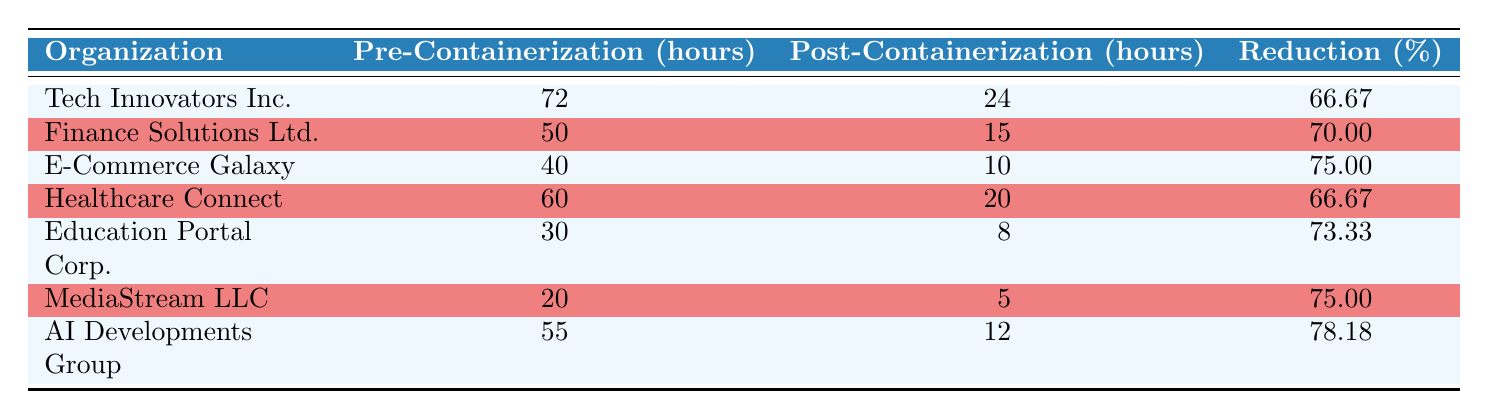What was the pre-containerization deployment time for E-Commerce Galaxy? The table shows that E-Commerce Galaxy had a pre-containerization deployment time of 40 hours.
Answer: 40 hours Which organization had the highest reduction percentage in deployment time? The organization with the highest reduction percentage is AI Developments Group, with a reduction of 78.18%.
Answer: AI Developments Group What is the total pre-containerization deployment time for all organizations? Adding up all the pre-containerization times gives us: 72 + 50 + 40 + 60 + 30 + 20 + 55 = 327 hours.
Answer: 327 hours Did Finance Solutions Ltd. have a reduction percentage of over 70%? According to the table, Finance Solutions Ltd. had a reduction percentage of 70.00%, which is equal to 70% but not greater than it.
Answer: No What is the average post-containerization deployment time across all organizations? To find the average, sum the post-containerization times: 24 + 15 + 10 + 20 + 8 + 5 + 12 = 94 hours, then divide by the number of organizations (7): 94/7 ≈ 13.43 hours.
Answer: 13.43 hours Was the post-containerization deployment time for Healthcare Connect less than 15 hours? The table shows that Healthcare Connect had a post-containerization deployment time of 20 hours, which is not less than 15 hours.
Answer: No Which organization experienced a reduction of 75% or more? By examining the reduction percentages, E-Commerce Galaxy, MediaStream LLC, and AI Developments Group all had reductions of 75% or more (75% and 78.18%).
Answer: E-Commerce Galaxy, MediaStream LLC, AI Developments Group What is the difference in hours between the pre-containerization and post-containerization deployment time for Tech Innovators Inc.? For Tech Innovators Inc., the difference is calculated as 72 hours (pre) - 24 hours (post) = 48 hours.
Answer: 48 hours 